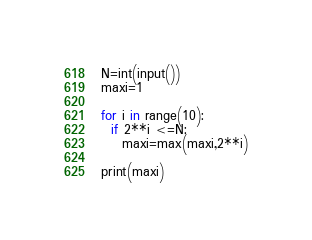<code> <loc_0><loc_0><loc_500><loc_500><_Python_>N=int(input())
maxi=1

for i in range(10):
  if 2**i <=N:
    maxi=max(maxi,2**i)
    
print(maxi)</code> 